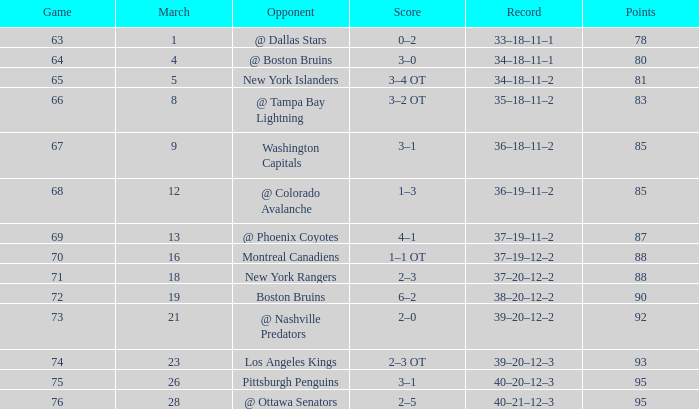How many Points have a Record of 40–21–12–3, and a March larger than 28? 0.0. 